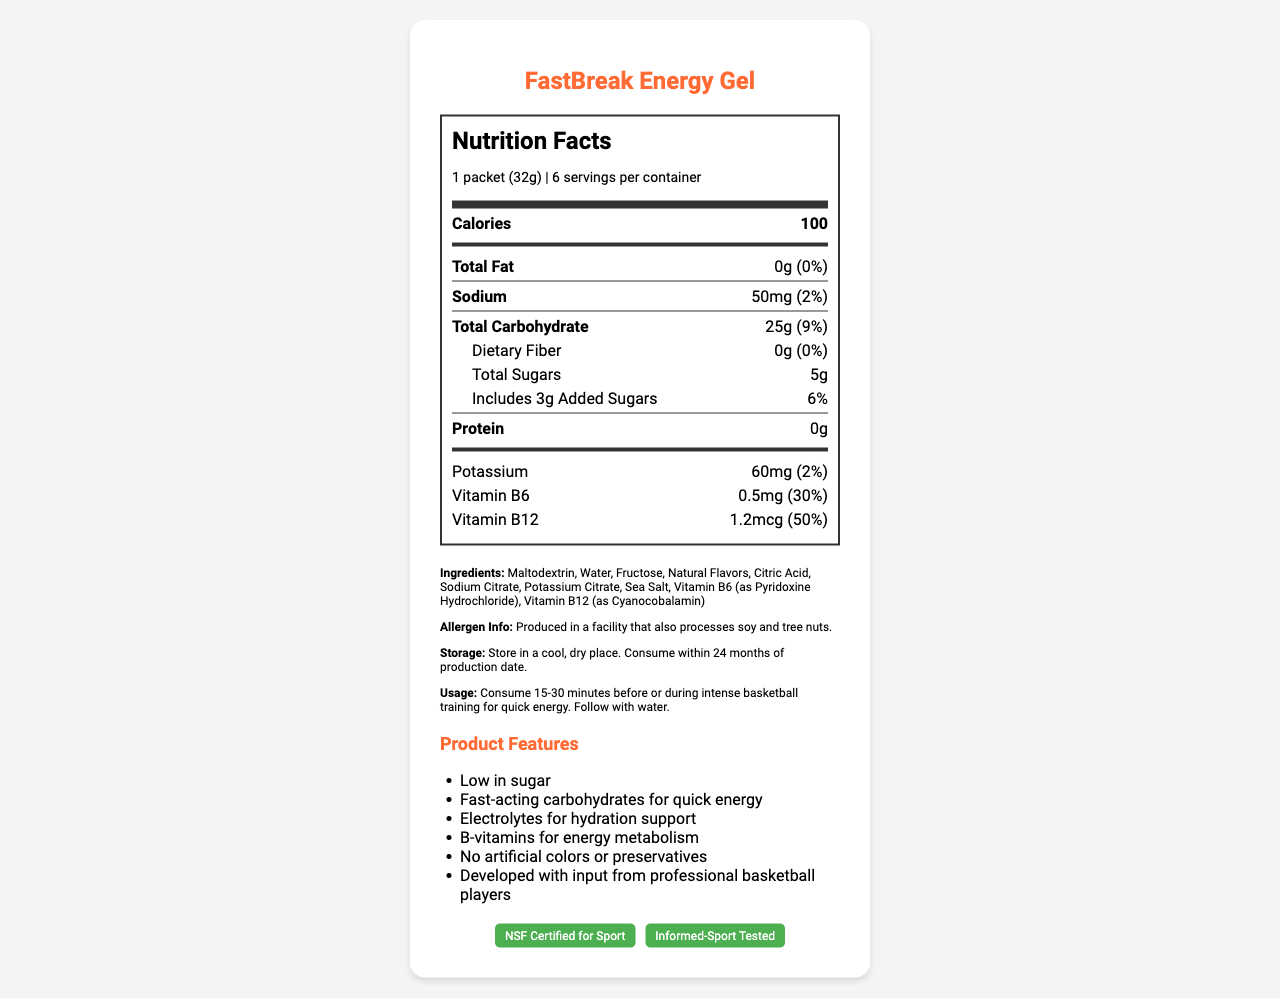what is the serving size of FastBreak Energy Gel? The serving size is listed as "1 packet (32g)" under the serving information.
Answer: 1 packet (32g) how many calories are in one serving of FastBreak Energy Gel? The Nutrition Facts section shows that there are 100 calories per serving.
Answer: 100 What is the daily value percentage for total carbohydrates in one serving? The label specifies that the total carbohydrate daily value percentage is 9%.
Answer: 9% What are the total sugars and added sugars in one serving of the gel? The label shows 5g total sugars and includes 3g of those as added sugars.
Answer: 5g total sugars, 3g added sugars Does FastBreak Energy Gel contain any dietary fiber? The Dietary Fiber section lists 0g and 0% daily value.
Answer: No What allergens are mentioned in the document? The allergen info states that it is produced in a facility that also processes soy and tree nuts.
Answer: Soy and tree nuts Does the FastBreak Energy Gel contain any protein? The protein amount listed on the label is 0g.
Answer: No When should you consume the FastBreak Energy Gel according to the usage instructions? The usage instructions advise to consume 15-30 minutes before or during intense basketball training for quick energy.
Answer: 15-30 minutes before or during intense basketball training List two vitamins found in FastBreak Energy Gel. The label indicates that the product contains Vitamin B6 and Vitamin B12.
Answer: Vitamin B6, Vitamin B12 What is one of the product features of the FastBreak Energy Gel? A. Contains artificial colors B. No artificial colors or preservatives C. Low in fat D. High in protein One of the listed product features is "No artificial colors or preservatives."
Answer: B How much potassium is in one serving of FastBreak Energy Gel? A. 30mg B. 45mg C. 60mg D. 80mg The nutrient line for potassium shows 60mg.
Answer: C Is the FastBreak Energy Gel certified for sport? The certifications section lists "NSF Certified for Sport" and "Informed-Sport Tested."
Answer: Yes Does FastBreak Energy Gel support hydration? One of the product features is "Electrolytes for hydration support."
Answer: Yes What is the main idea of the document? The document includes the product's nutrition facts, ingredients list, usage instructions, allergen information, product features, and certifications.
Answer: The document provides nutrition facts, ingredients, and usage information for FastBreak Energy Gel, which is designed to give quick energy during intense basketball training sessions. How much daily value percentage of Vitamin B12 is provided per serving? The nutrition label shows that Vitamin B12 contributes to 50% of the daily value per serving.
Answer: 50% Why should the storage instructions be followed? The document only provides the storage instructions but doesn't explain why they should be followed.
Answer: Cannot be determined 